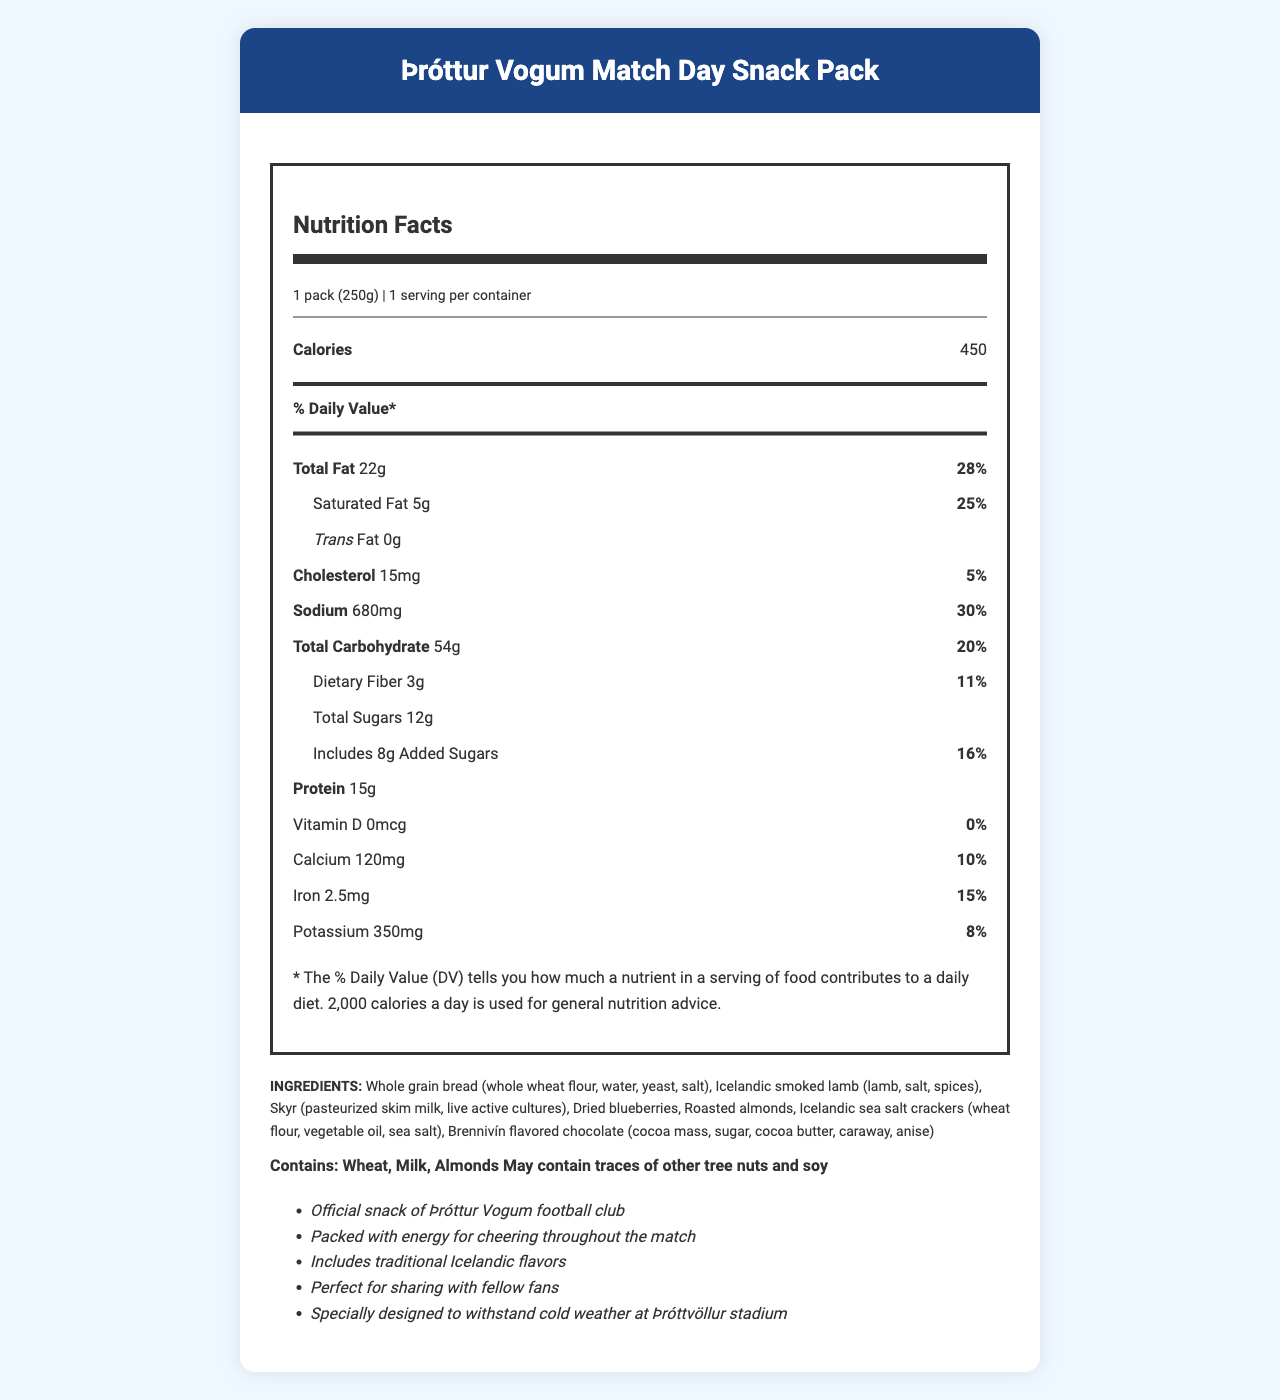what is the serving size of the snack pack? The serving size is clearly stated in the serving information section at the top of the nutrition label.
Answer: 1 pack (250g) how many calories are in a serving? The number of calories per serving is displayed prominently in the nutrition facts section.
Answer: 450 what is the total fat content and its percentage daily value? The total fat content and its corresponding daily value percentage are both listed together in the nutrition facts.
Answer: 22g, 28% how much sodium is in the snack pack and what is its daily value percentage? The amount of sodium and its daily value percentage are specified in the nutrition facts.
Answer: 680mg, 30% what are the ingredients in the snack pack? The ingredient list is found at the end of the document under the heading INGREDIENTS.
Answer: Whole grain bread (whole wheat flour, water, yeast, salt), Icelandic smoked lamb (lamb, salt, spices), Skyr (pasteurized skim milk, live active cultures), Dried blueberries, Roasted almonds, Icelandic sea salt crackers (wheat flour, vegetable oil, sea salt), Brennivín flavored chocolate (cocoa mass, sugar, cocoa butter, caraway, anise) what allergens are present in the snack pack? The allergens are listed under the allergens section.
Answer: Contains: Wheat, Milk, Almonds. May contain traces of other tree nuts and soy how much protein does the snack pack contain? The amount of protein is listed clearly in the nutrition facts section.
Answer: 15g how much added sugar is in the snack pack and what percentage of the daily value does it represent? The amount of added sugar and its daily value percentage are specified in the nutrition facts.
Answer: 8g, 16% what is the calcium content and its daily value percentage? The calcium content and its daily value percentage are listed in the nutrition facts section.
Answer: 120mg, 10% which of the following vitamins and minerals have the largest daily value percentage in the snack pack? A. Calcium B. Iron C. Potassium D. Vitamin D Iron has a daily value of 15%, making it the largest among the listed options.
Answer: B. Iron what traditional Icelandic ingredient is included in the snack pack? A. Icelandic smoked lamb B. Skyr C. Brennivín flavored chocolate D. All of the above The document mentions that the snack pack includes traditional Icelandic flavors, specifically listing Icelandic smoked lamb, Skyr, and Brennivín flavored chocolate among the ingredients.
Answer: D. All of the above is this snack pack suitable for someone with a tree nut allergy? The allergens section mentions that the snack pack contains almonds and may contain traces of other tree nuts.
Answer: No summarize the main idea of the document. This summary encapsulates the primary focus areas of the document, which include nutritional information, ingredients, allergens, and promotional highlights.
Answer: The document provides detailed nutrition facts, ingredient information, allergen warnings, and additional promotional details for the Þróttur Vogum Match Day Snack Pack, an official snack designed for fans attending football matches at Þróttvöllur stadium. what is the exact flavor profile of the chocolate included in the snack pack? The document mentions that the chocolate is Brennivín flavored but does not provide a detailed flavor profile.
Answer: Not enough information 